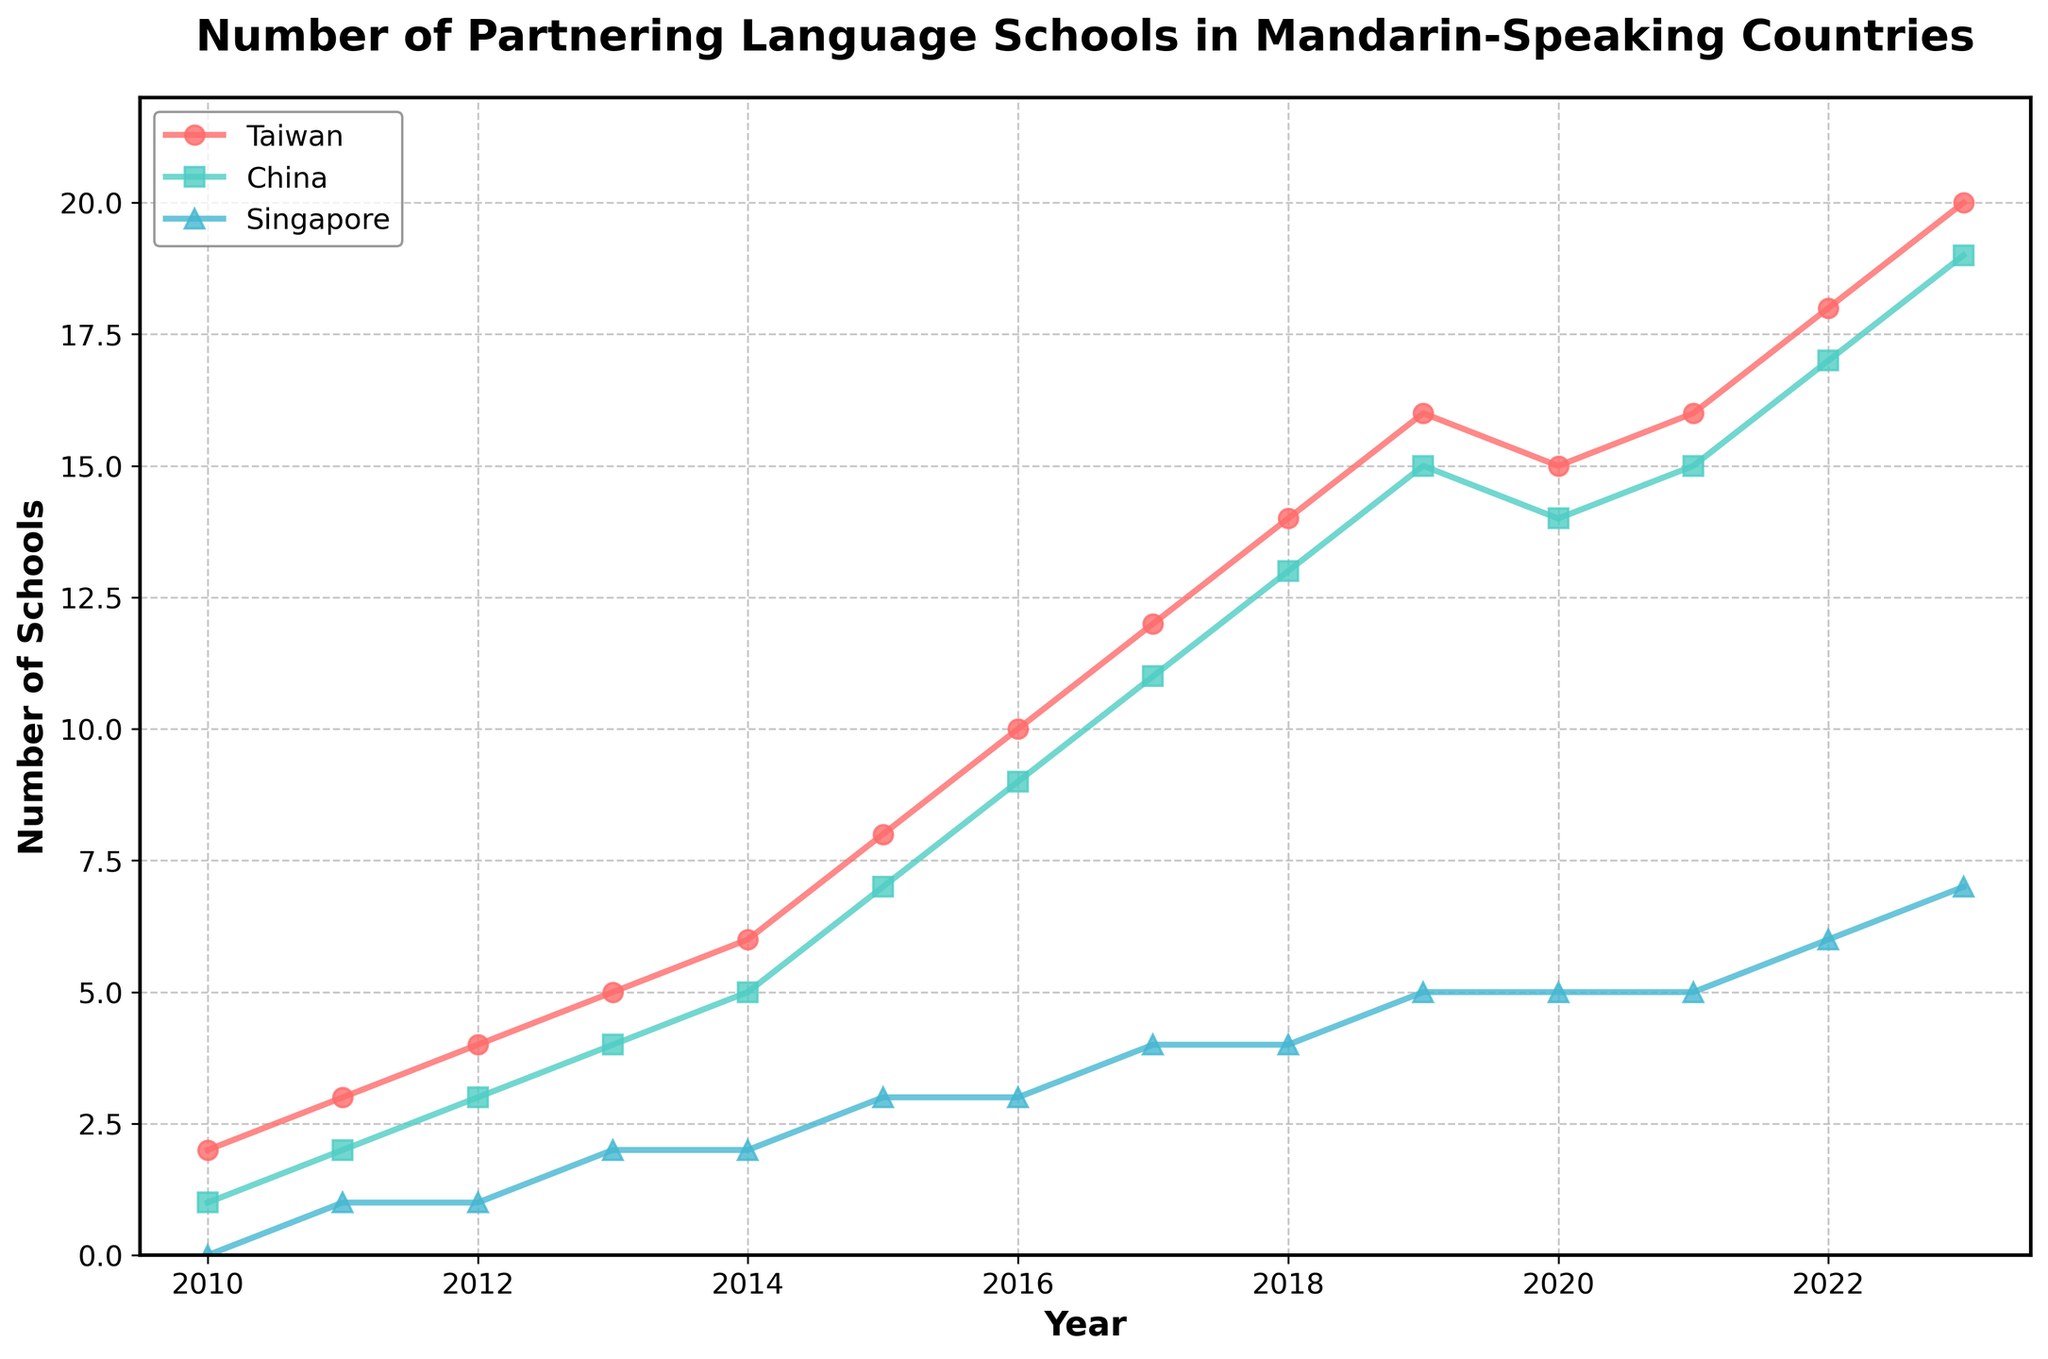Which country had the most significant increase in the number of schools between 2010 and 2023? To find the country with the most significant increase, subtract the number of schools in 2010 from the number in 2023 for each country. For Taiwan, the increase is 20 - 2 = 18; for China, it is 19 - 1 = 18; for Singapore, it is 7 - 0 = 7. Taiwan and China both had an increase of 18 schools.
Answer: Taiwan and China How many total partnering schools were there across all countries in 2015? Sum the number of schools for Taiwan, China, and Singapore in 2015. The total is 8 (Taiwan) + 7 (China) + 3 (Singapore) = 18.
Answer: 18 In which year did Taiwan first surpass 15 partnering schools? Check the plotted values for Taiwan to see when it first reached or surpassed 15. The plotted value crosses 15 in 2019.
Answer: 2019 By how many schools did China's partnering schools increase from 2014 to 2017? Subtract the number of schools in China in 2014 from the number in 2017. The increase is 11 - 5 = 6.
Answer: 6 What trend do you observe for Singapore’s partnering schools after 2014? Visually inspect the trend of Singapore’s plot line after 2014. The number of schools in Singapore shows a steady increase from 2 in 2014 to 7 in 2023.
Answer: Steady increase In which year did China’s number of partnering schools reach 9? Locate the plotted value for China that corresponds to 9 schools. In 2016, China had 9 partnering schools.
Answer: 2016 Compare the number of schools in Taiwan and Singapore in 2018. Which one had more, and by how many? Taiwan had 14 partnering schools, and Singapore had 4. Taiwan had 14 - 4 = 10 more schools than Singapore in 2018.
Answer: Taiwan by 10 Which country experienced the largest drop in the number of partnering schools between 2019 and 2020? Compare the difference in the number of schools for each country between these years. Taiwan dropped from 16 to 15 (1 school), China from 15 to 14 (1 school), and Singapore had no change. Both Taiwan and China experienced the largest drop of 1 school.
Answer: Taiwan and China For which year was the number of partnering schools in Taiwan the same as in China? Inspect the plot lines to find when the number of schools for Taiwan and China are equal. Both had 15 partnering schools in 2021.
Answer: 2021 